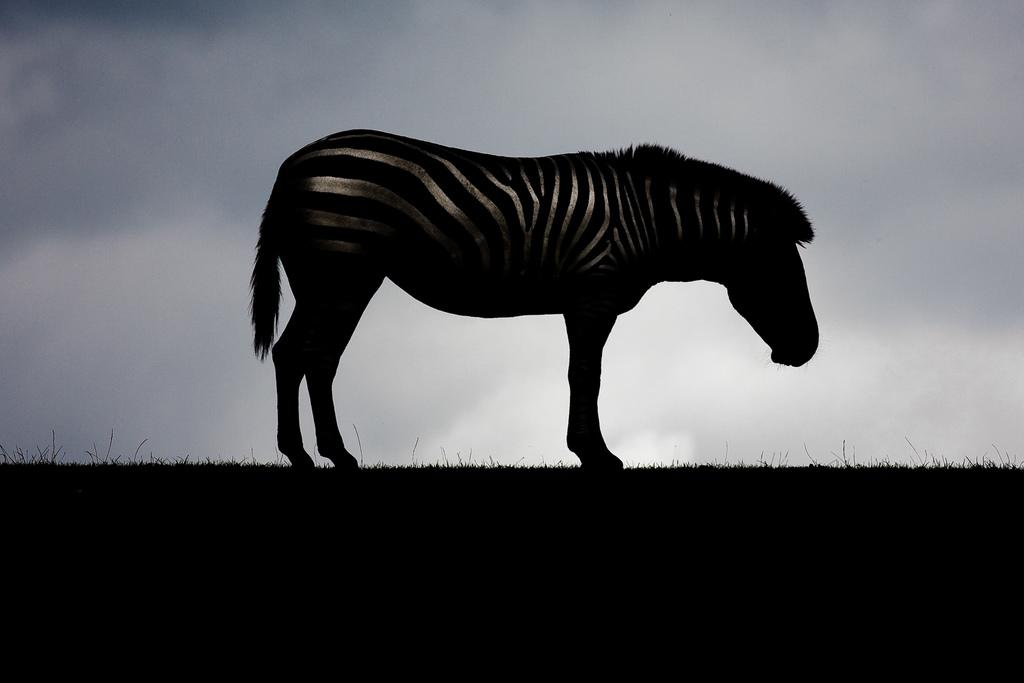What animal is in the image? There is a zebra in the image. What is the zebra standing on? The zebra is standing on the grass. What can be seen in the background of the image? There is a sky visible in the background of the image. What is the weather like in the image? The presence of dark clouds in the sky suggests that the weather might be cloudy or overcast. What type of soup is being served in the image? There is no soup present in the image; it features a zebra standing on grass with a sky visible in the background. Are there any cacti visible in the image? There are no cacti present in the image; it features a zebra standing on grass with a sky visible in the background. 